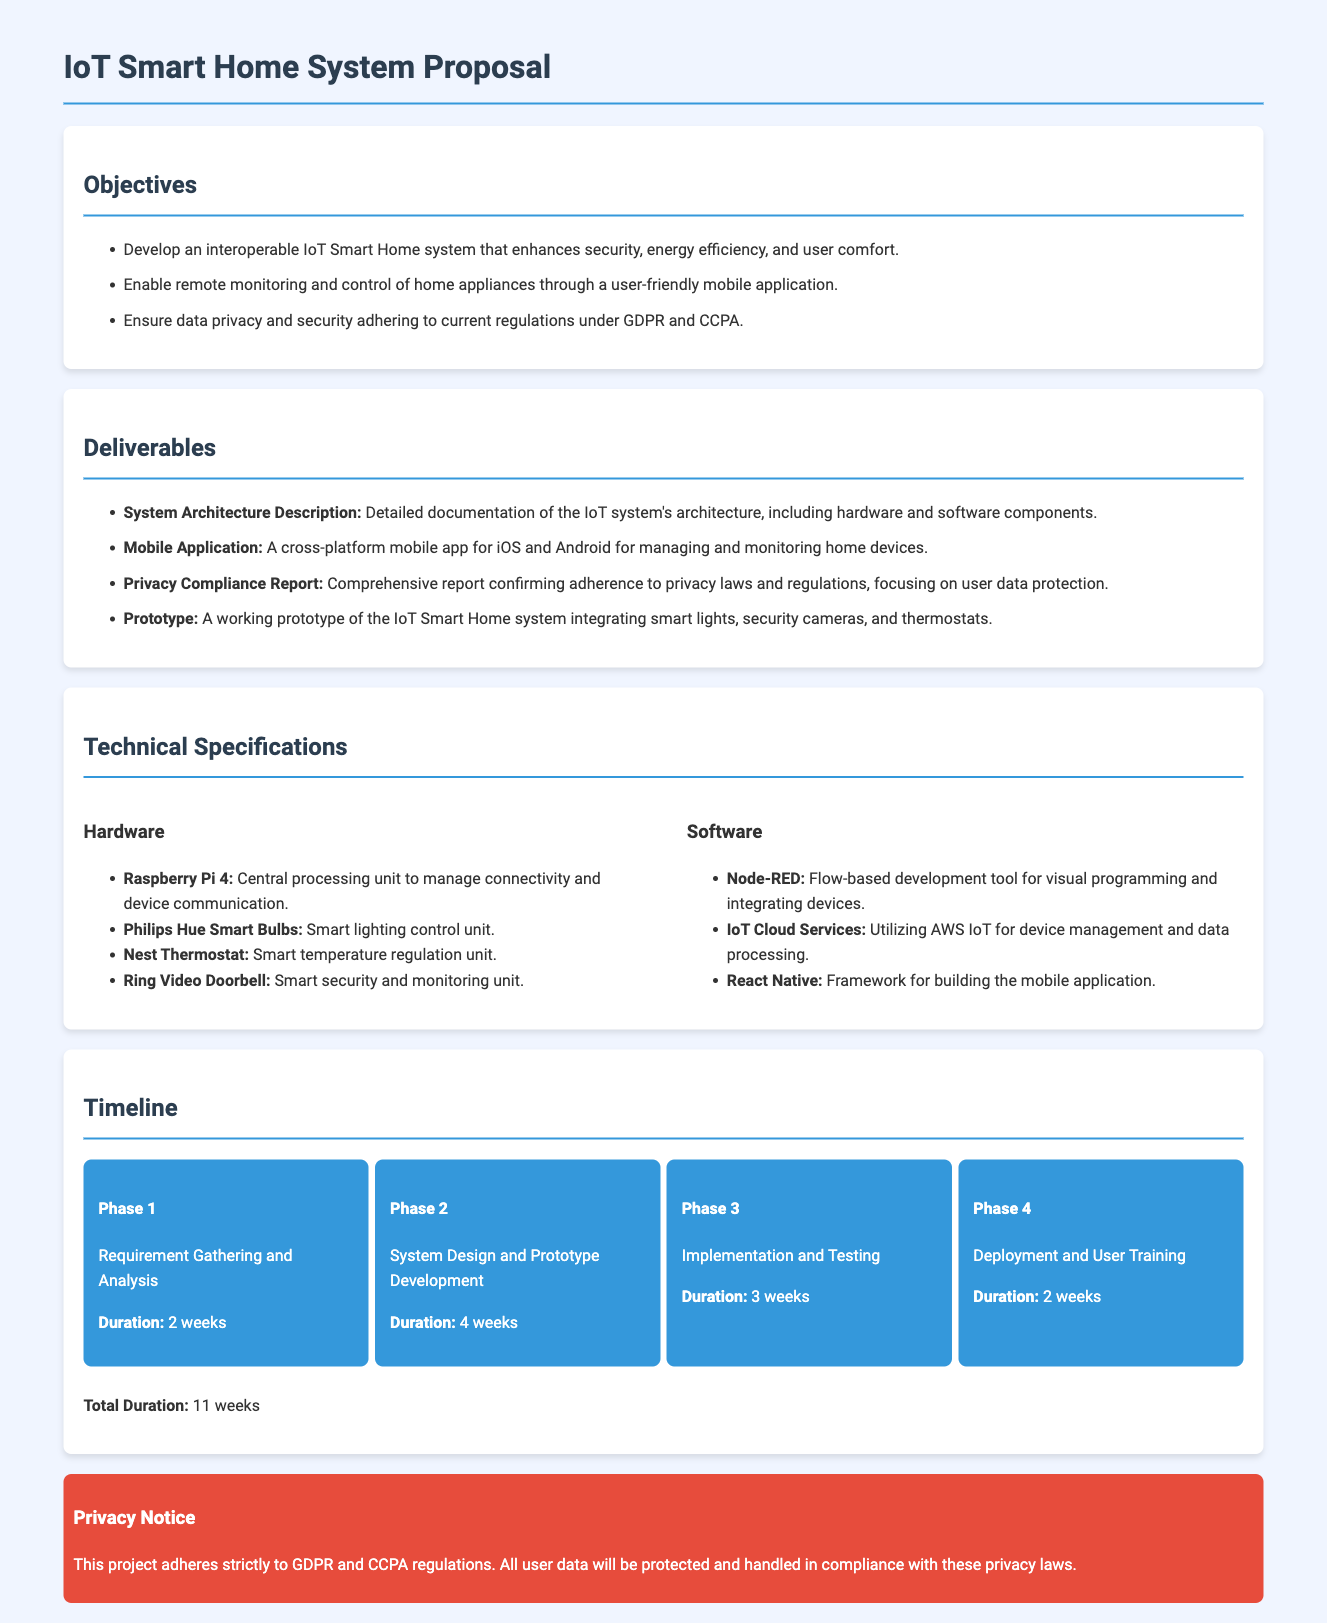What are the three main objectives of the project? The objectives include enhancing security, energy efficiency, and user comfort in the IoT Smart Home system.
Answer: security, energy efficiency, user comfort How long is the total project duration? The total duration sums up all phases: 2 weeks + 4 weeks + 3 weeks + 2 weeks = 11 weeks.
Answer: 11 weeks What hardware component is used for central processing? The hardware section lists Raspberry Pi 4 as the central processing unit for the system.
Answer: Raspberry Pi 4 What is included in the privacy compliance report? The report confirms adherence to privacy laws and its focus is on user data protection.
Answer: user data protection What is the duration of the implementation and testing phase? This phase lasts for 3 weeks, as stated in the timeline section.
Answer: 3 weeks Which mobile application framework is mentioned? The document specifies React Native as the framework for building the mobile application.
Answer: React Native What is the primary purpose of the mobile application? The mobile application allows remote monitoring and control of home appliances.
Answer: remote monitoring and control What is the focus of the privacy notice provided in the document? The privacy notice emphasizes adherence to GDPR and CCPA regulations regarding user data.
Answer: GDPR and CCPA What are the deliverables related to system architecture? The deliverable is a detailed documentation of the IoT system's architecture and its components.
Answer: System Architecture Description 